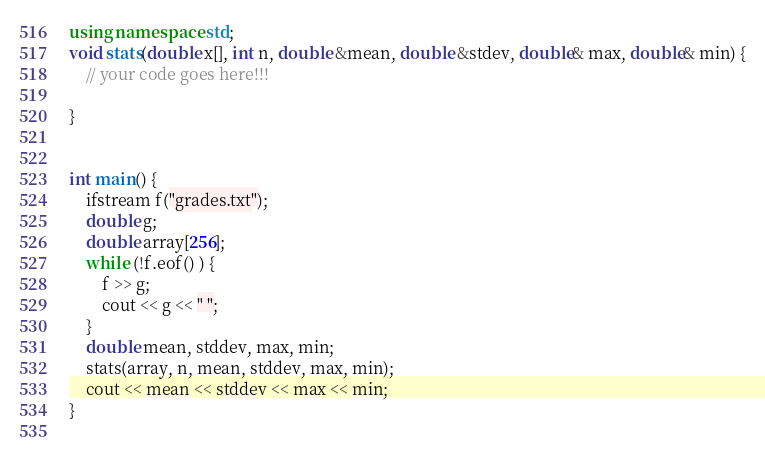<code> <loc_0><loc_0><loc_500><loc_500><_C++_>using namespace std;
void stats(double x[], int n, double &mean, double &stdev, double& max, double& min) {
	// your code goes here!!!

}


int main() {
	ifstream f("grades.txt");
	double g;
	double array[256];
	while (!f.eof() ) {
		f >> g;
		cout << g << " ";
	}
	double mean, stddev, max, min;
	stats(array, n, mean, stddev, max, min);
	cout << mean << stddev << max << min;
}
	
</code> 